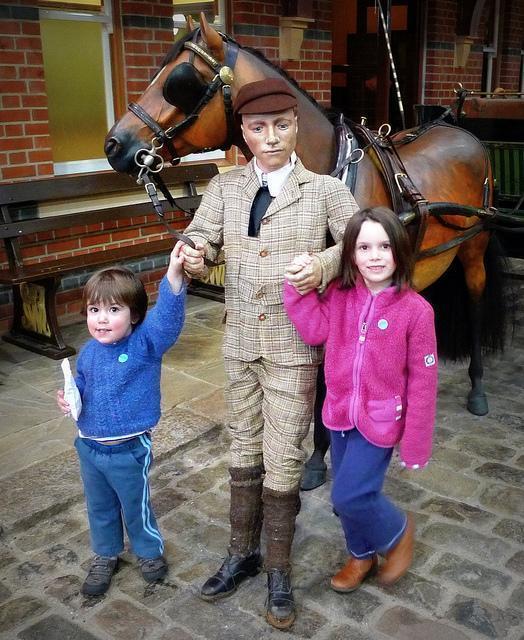What type of material makes up a majority of the construction in the area?
Answer the question by selecting the correct answer among the 4 following choices.
Options: Stone, steel, wood, mud. Stone. 